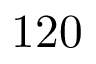<formula> <loc_0><loc_0><loc_500><loc_500>1 2 0</formula> 